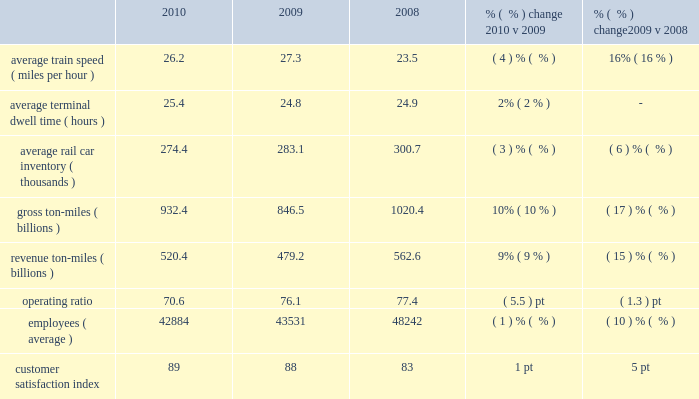Operating/performance statistics railroad performance measures reported to the aar , as well as other performance measures , are included in the table below : 2010 2009 2008 % (  % ) change 2010 v 2009 % (  % ) change 2009 v 2008 .
Average train speed 2013 average train speed is calculated by dividing train miles by hours operated on our main lines between terminals .
Maintenance activities and weather disruptions , combined with higher volume levels , led to a 4% ( 4 % ) decrease in average train speed in 2010 compared to a record set in 2009 .
Overall , we continued operating a fluid and efficient network during the year .
Lower volume levels , ongoing network management initiatives , and productivity improvements contributed to a 16% ( 16 % ) improvement in average train speed in 2009 compared to 2008 .
Average terminal dwell time 2013 average terminal dwell time is the average time that a rail car spends at our terminals .
Lower average terminal dwell time improves asset utilization and service .
Average terminal dwell time increased 2% ( 2 % ) in 2010 compared to 2009 , driven in part by our network plan to increase the length of numerous trains to improve overall efficiency , which resulted in higher terminal dwell time for some cars .
Average terminal dwell time improved slightly in 2009 compared to 2008 due to lower volume levels combined with initiatives to expedite delivering rail cars to our interchange partners and customers .
Average rail car inventory 2013 average rail car inventory is the daily average number of rail cars on our lines , including rail cars in storage .
Lower average rail car inventory reduces congestion in our yards and sidings , which increases train speed , reduces average terminal dwell time , and improves rail car utilization .
Average rail car inventory decreased 3% ( 3 % ) in 2010 compared to 2009 , while we handled 13% ( 13 % ) increases in carloads during the period compared to 2009 .
We maintained more freight cars off-line and retired a number of old freight cars , which drove the decreases .
Average rail car inventory decreased 6% ( 6 % ) in 2009 compared to 2008 driven by a 16% ( 16 % ) decrease in volume .
In addition , as carloads decreased , we stored more freight cars off-line .
Gross and revenue ton-miles 2013 gross ton-miles are calculated by multiplying the weight of loaded and empty freight cars by the number of miles hauled .
Revenue ton-miles are calculated by multiplying the weight of freight by the number of tariff miles .
Gross and revenue-ton-miles increased 10% ( 10 % ) and 9% ( 9 % ) in 2010 compared to 2009 due to a 13% ( 13 % ) increase in carloads .
Commodity mix changes ( notably automotive shipments ) drove the variance in year-over-year growth between gross ton-miles , revenue ton-miles and carloads .
Gross and revenue ton-miles decreased 17% ( 17 % ) and 15% ( 15 % ) in 2009 compared to 2008 due to a 16% ( 16 % ) decrease in carloads .
Commodity mix changes ( notably automotive shipments , which were 30% ( 30 % ) lower in 2009 versus 2008 ) drove the difference in declines between gross ton-miles and revenue ton- miles .
Operating ratio 2013 operating ratio is defined as our operating expenses as a percentage of operating revenue .
Our operating ratio improved 5.5 points to 70.6% ( 70.6 % ) in 2010 and 1.3 points to 76.1% ( 76.1 % ) in 2009 .
Efficiently leveraging volume increases , core pricing gains , and productivity initiatives drove the improvement in 2010 and more than offset the impact of higher fuel prices during the year .
Core pricing gains , lower fuel prices , network management initiatives , and improved productivity drove the improvement in 2009 and more than offset the 16% ( 16 % ) volume decline .
Employees 2013 employee levels were down 1% ( 1 % ) in 2010 compared to 2009 despite a 13% ( 13 % ) increase in volume levels .
We leveraged the additional volumes through network efficiencies and other productivity initiatives .
In addition , we successfully managed the growth of our full-time-equivalent train and engine force levels at a rate less than half of our carload growth in 2010 .
All other operating functions and .
What is the mathematical range for average train speed ( mph ) for 2008-2010? 
Computations: (27.3 - 23.5)
Answer: 3.8. 